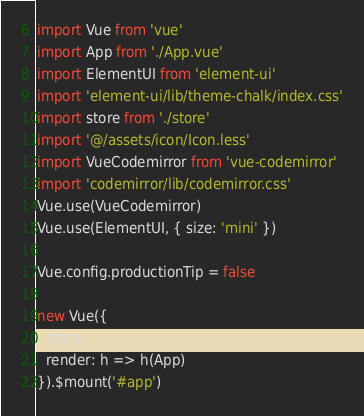Convert code to text. <code><loc_0><loc_0><loc_500><loc_500><_JavaScript_>import Vue from 'vue'
import App from './App.vue'
import ElementUI from 'element-ui'
import 'element-ui/lib/theme-chalk/index.css'
import store from './store'
import '@/assets/icon/Icon.less'
import VueCodemirror from 'vue-codemirror'
import 'codemirror/lib/codemirror.css'
Vue.use(VueCodemirror)
Vue.use(ElementUI, { size: 'mini' })

Vue.config.productionTip = false

new Vue({
  store,
  render: h => h(App)
}).$mount('#app')
</code> 